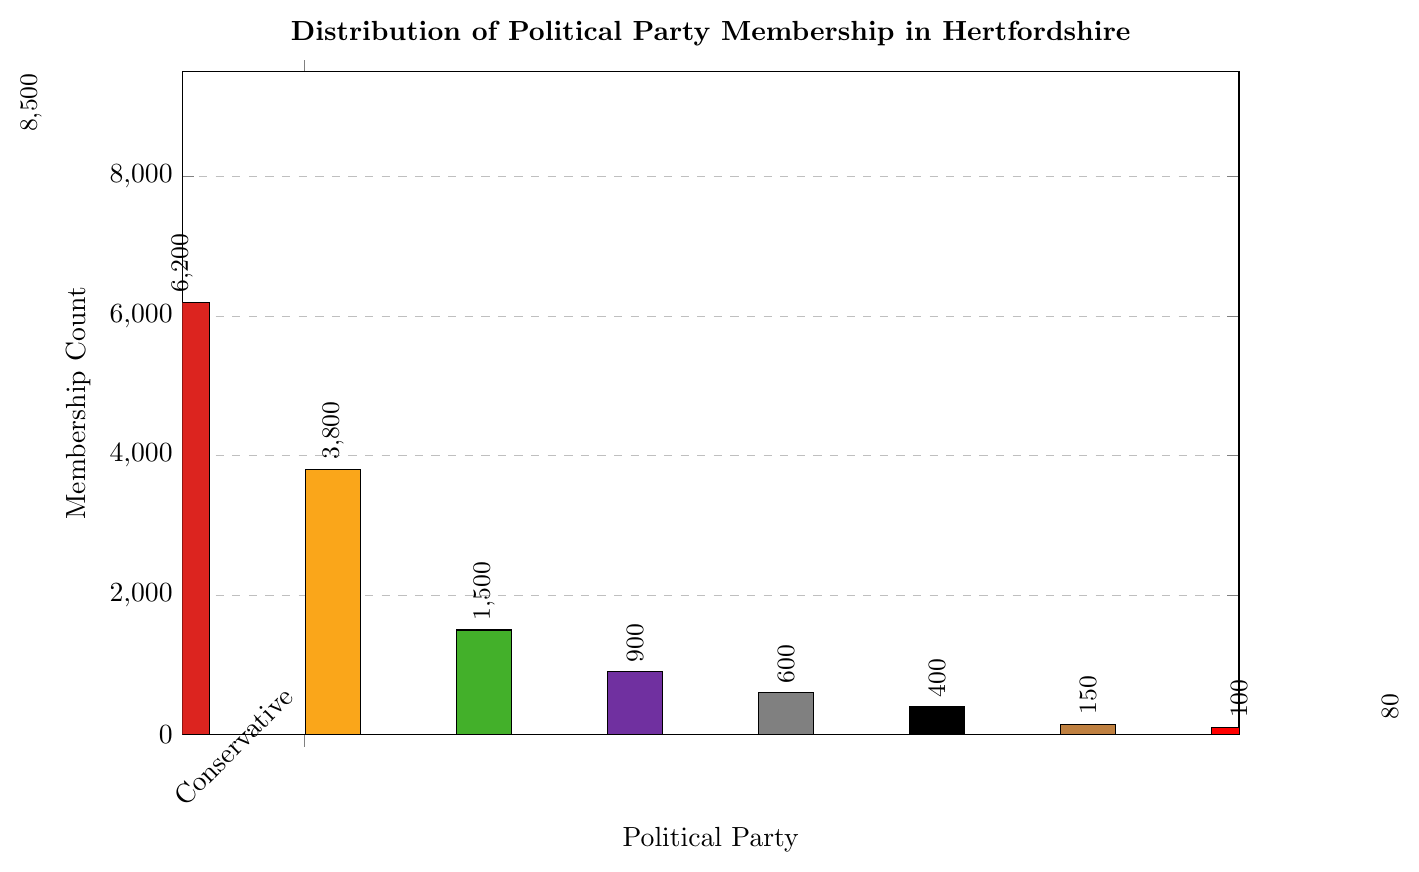What's the membership difference between the Conservative Party and Labour Party? From the bar chart, the membership of the Conservative Party is 8500 and the Labour Party is 6200. The difference is 8500 - 6200 = 2300.
Answer: 2300 Which party has the lowest membership count and what is it? From the bar chart, the Women's Equality Party has the lowest membership count, indicated by the shortest bar. The count is 80 members.
Answer: Women's Equality Party, 80 How many parties have a membership count of fewer than 1000? From the bar chart, the parties with fewer than 1000 members are UKIP (900), Reform UK (600), Independent (400), British National Party (150), Socialist Party (100), and Women's Equality Party (80). There are 6 parties in total.
Answer: 6 What is the total membership count of the top three parties? The top three parties by membership count are Conservative Party (8500), Labour Party (6200), and Liberal Democrats (3800). The total is 8500 + 6200 + 3800 = 18500.
Answer: 18500 What is the average membership count across all parties? The membership counts for each party are 8500, 6200, 3800, 1500, 900, 600, 400, 150, 100, and 80. The sum of these counts is 8500 + 6200 + 3800 + 1500 + 900 + 600 + 400 + 150 + 100 + 80 = 22130. There are 10 parties, so the average is 22130 / 10 = 2213.
Answer: 2213 Which party has more members, Green Party or UK Independence Party, and by how much? From the bar chart, the Green Party has 1500 members and UK Independence Party has 900 members. The Green Party has 1500 - 900 = 600 more members.
Answer: Green Party, 600 What is the membership percentage of the Labour Party out of the total membership? The Labour Party has 6200 members. The total membership across all parties is 22130. The percentage is (6200 / 22130) * 100 ≈ 28.01%.
Answer: 28.01% Which parties have a membership count greater than 1000 but less than 5000? From the bar chart, the parties that meet this criterion are Liberal Democrats (3800) and Green Party (1500).
Answer: Liberal Democrats, Green Party How does the membership of Independent compare to British National Party and Socialist Party combined? The Independent party has 400 members. The British National Party and Socialist Party combined have 150 + 100 = 250 members. The difference is 400 - 250 = 150 more members in the Independent party.
Answer: 150 more members What proportion of the total membership do the bottom four parties represent? The bottom four parties are Independent (400), British National Party (150), Socialist Party (100), and Women's Equality Party (80). Their total membership is 400 + 150 + 100 + 80 = 730. The total membership across all parties is 22130. The proportion is (730 / 22130) * 100 ≈ 3.30%.
Answer: 3.30% 